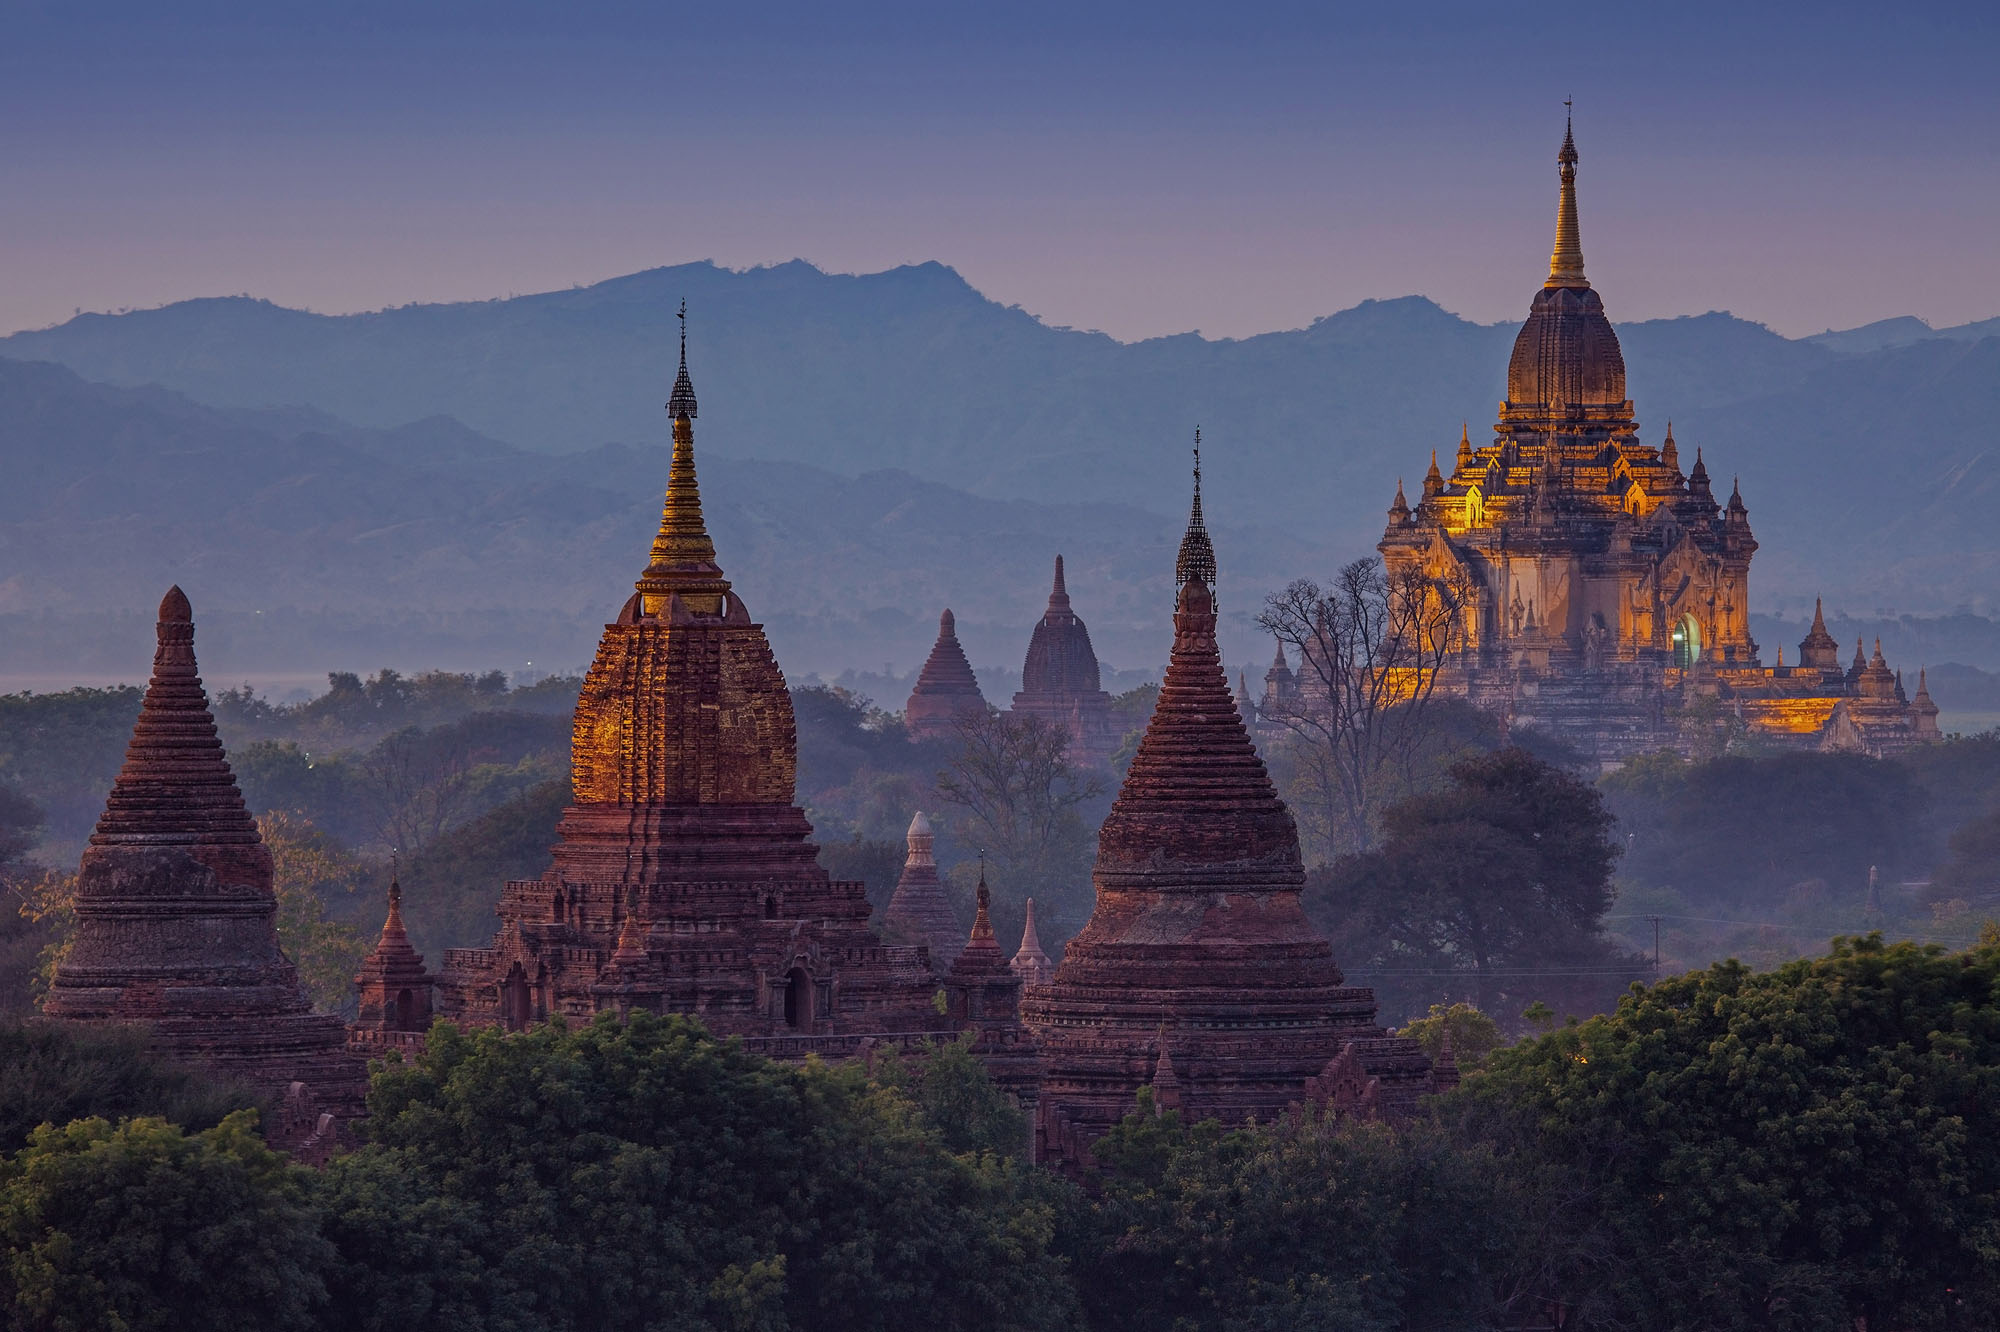If you could transform into an inanimate object in this scene, what would it be and why? If I could transform into an inanimate object in this scene, I would choose to be the golden spire atop one of the ancient pagodas. Perched high above the ground, I would bask in the warmth of the setting sun, shimmering like a beacon of hope and spirituality. From my vantage point, I would witness the panoramic splendor of Bagan every day, observing how the hues of the sky change from the first light of dawn to the twilight hour. I would feel connected to the deep spiritual devotion of the countless monks and pilgrims who have visited these sacred temples over the centuries, their prayers and chants resonating through my very being. This enduring connection to history, spirituality, and the breathtaking beauty of nature would make the experience truly magical. 